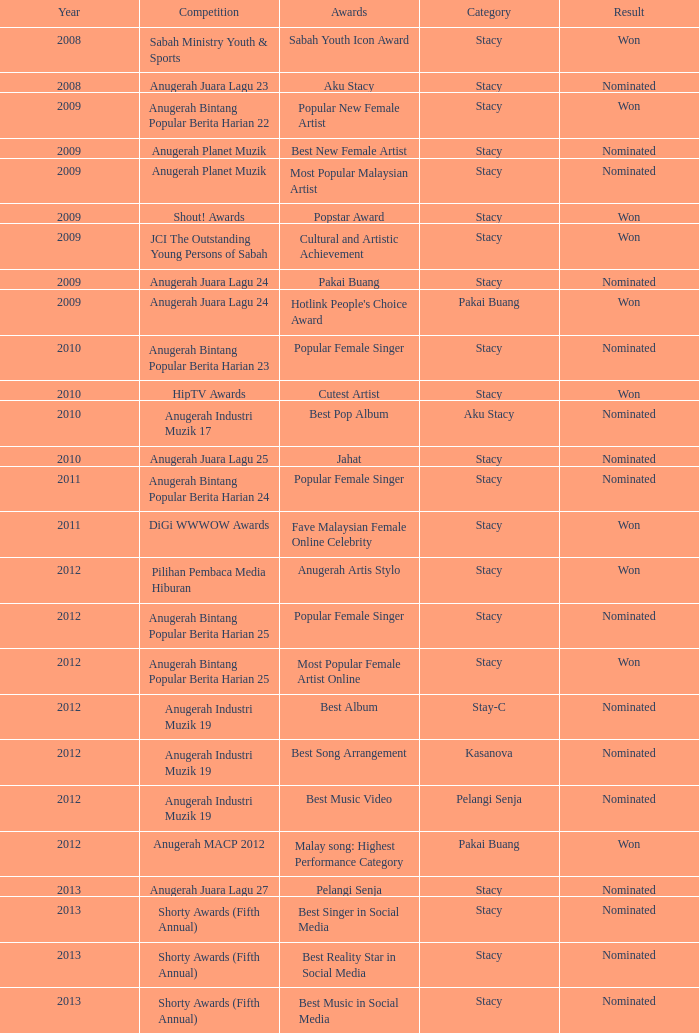In the year succeeding 2009, what award was associated with the digi wwwow awards competition? Fave Malaysian Female Online Celebrity. 